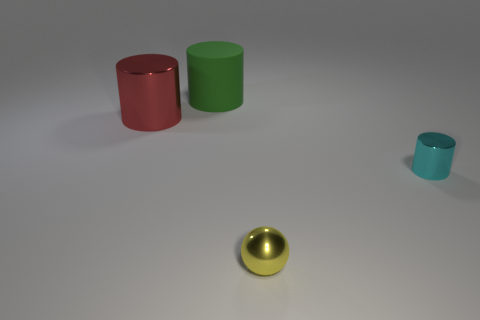The cyan thing that is made of the same material as the yellow ball is what shape?
Offer a terse response. Cylinder. What is the size of the thing in front of the tiny cyan thing?
Keep it short and to the point. Small. There is a big green rubber thing; what shape is it?
Your answer should be compact. Cylinder. There is a cylinder on the right side of the large green matte cylinder; is it the same size as the yellow metallic thing that is on the right side of the large metal cylinder?
Your answer should be very brief. Yes. What is the size of the shiny thing that is on the left side of the tiny thing that is in front of the cylinder in front of the large red cylinder?
Your answer should be very brief. Large. There is a metallic object that is in front of the metal cylinder that is on the right side of the large cylinder that is behind the big shiny thing; what is its shape?
Offer a terse response. Sphere. There is a thing that is in front of the tiny cyan shiny thing; what shape is it?
Offer a terse response. Sphere. Does the big green cylinder have the same material as the tiny thing that is behind the small yellow metallic ball?
Your answer should be compact. No. What number of other objects are the same shape as the large matte object?
Ensure brevity in your answer.  2. Are there any other things that have the same material as the green object?
Give a very brief answer. No. 